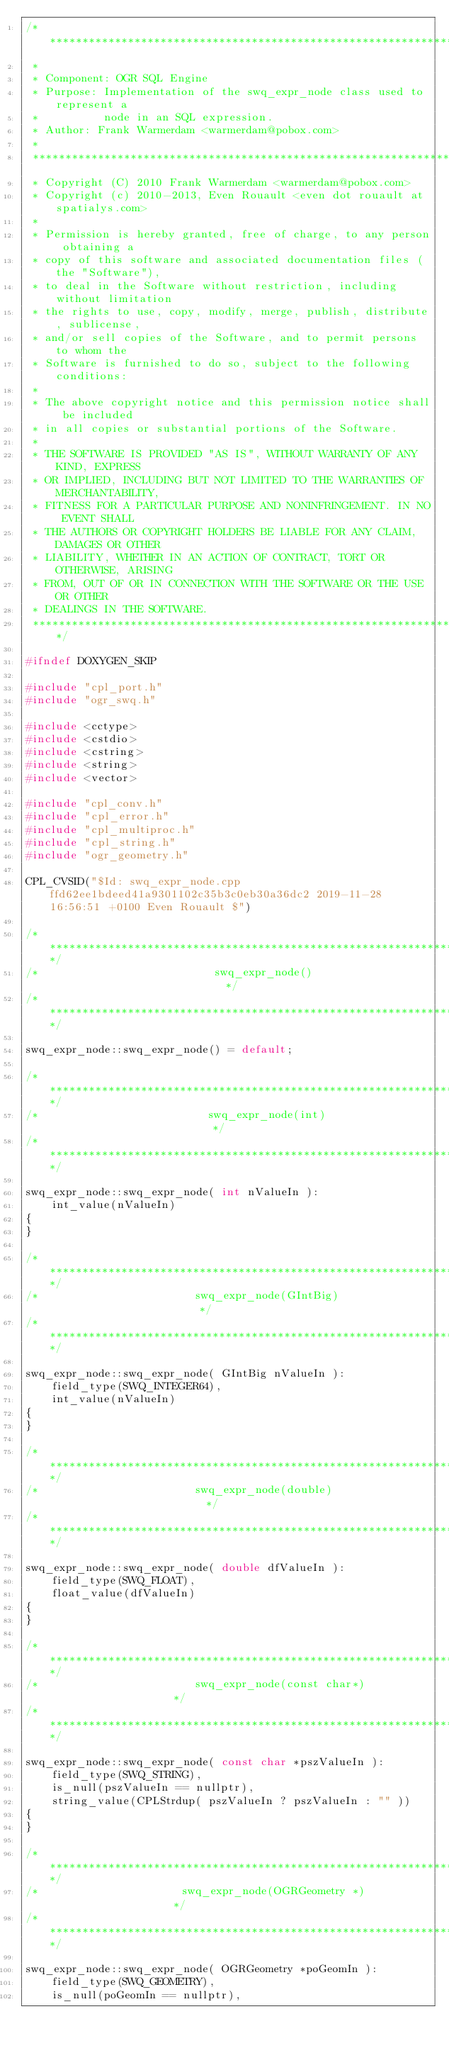<code> <loc_0><loc_0><loc_500><loc_500><_C++_>/******************************************************************************
 *
 * Component: OGR SQL Engine
 * Purpose: Implementation of the swq_expr_node class used to represent a
 *          node in an SQL expression.
 * Author: Frank Warmerdam <warmerdam@pobox.com>
 *
 ******************************************************************************
 * Copyright (C) 2010 Frank Warmerdam <warmerdam@pobox.com>
 * Copyright (c) 2010-2013, Even Rouault <even dot rouault at spatialys.com>
 *
 * Permission is hereby granted, free of charge, to any person obtaining a
 * copy of this software and associated documentation files (the "Software"),
 * to deal in the Software without restriction, including without limitation
 * the rights to use, copy, modify, merge, publish, distribute, sublicense,
 * and/or sell copies of the Software, and to permit persons to whom the
 * Software is furnished to do so, subject to the following conditions:
 *
 * The above copyright notice and this permission notice shall be included
 * in all copies or substantial portions of the Software.
 *
 * THE SOFTWARE IS PROVIDED "AS IS", WITHOUT WARRANTY OF ANY KIND, EXPRESS
 * OR IMPLIED, INCLUDING BUT NOT LIMITED TO THE WARRANTIES OF MERCHANTABILITY,
 * FITNESS FOR A PARTICULAR PURPOSE AND NONINFRINGEMENT. IN NO EVENT SHALL
 * THE AUTHORS OR COPYRIGHT HOLDERS BE LIABLE FOR ANY CLAIM, DAMAGES OR OTHER
 * LIABILITY, WHETHER IN AN ACTION OF CONTRACT, TORT OR OTHERWISE, ARISING
 * FROM, OUT OF OR IN CONNECTION WITH THE SOFTWARE OR THE USE OR OTHER
 * DEALINGS IN THE SOFTWARE.
 ****************************************************************************/

#ifndef DOXYGEN_SKIP

#include "cpl_port.h"
#include "ogr_swq.h"

#include <cctype>
#include <cstdio>
#include <cstring>
#include <string>
#include <vector>

#include "cpl_conv.h"
#include "cpl_error.h"
#include "cpl_multiproc.h"
#include "cpl_string.h"
#include "ogr_geometry.h"

CPL_CVSID("$Id: swq_expr_node.cpp ffd62ee1bdeed41a9301102c35b3c0eb30a36dc2 2019-11-28 16:56:51 +0100 Even Rouault $")

/************************************************************************/
/*                           swq_expr_node()                            */
/************************************************************************/

swq_expr_node::swq_expr_node() = default;

/************************************************************************/
/*                          swq_expr_node(int)                          */
/************************************************************************/

swq_expr_node::swq_expr_node( int nValueIn ):
    int_value(nValueIn)
{
}

/************************************************************************/
/*                        swq_expr_node(GIntBig)                        */
/************************************************************************/

swq_expr_node::swq_expr_node( GIntBig nValueIn ):
    field_type(SWQ_INTEGER64),
    int_value(nValueIn)
{
}

/************************************************************************/
/*                        swq_expr_node(double)                         */
/************************************************************************/

swq_expr_node::swq_expr_node( double dfValueIn ):
    field_type(SWQ_FLOAT),
    float_value(dfValueIn)
{
}

/************************************************************************/
/*                        swq_expr_node(const char*)                    */
/************************************************************************/

swq_expr_node::swq_expr_node( const char *pszValueIn ):
    field_type(SWQ_STRING),
    is_null(pszValueIn == nullptr),
    string_value(CPLStrdup( pszValueIn ? pszValueIn : "" ))
{
}

/************************************************************************/
/*                      swq_expr_node(OGRGeometry *)                    */
/************************************************************************/

swq_expr_node::swq_expr_node( OGRGeometry *poGeomIn ):
    field_type(SWQ_GEOMETRY),
    is_null(poGeomIn == nullptr),</code> 